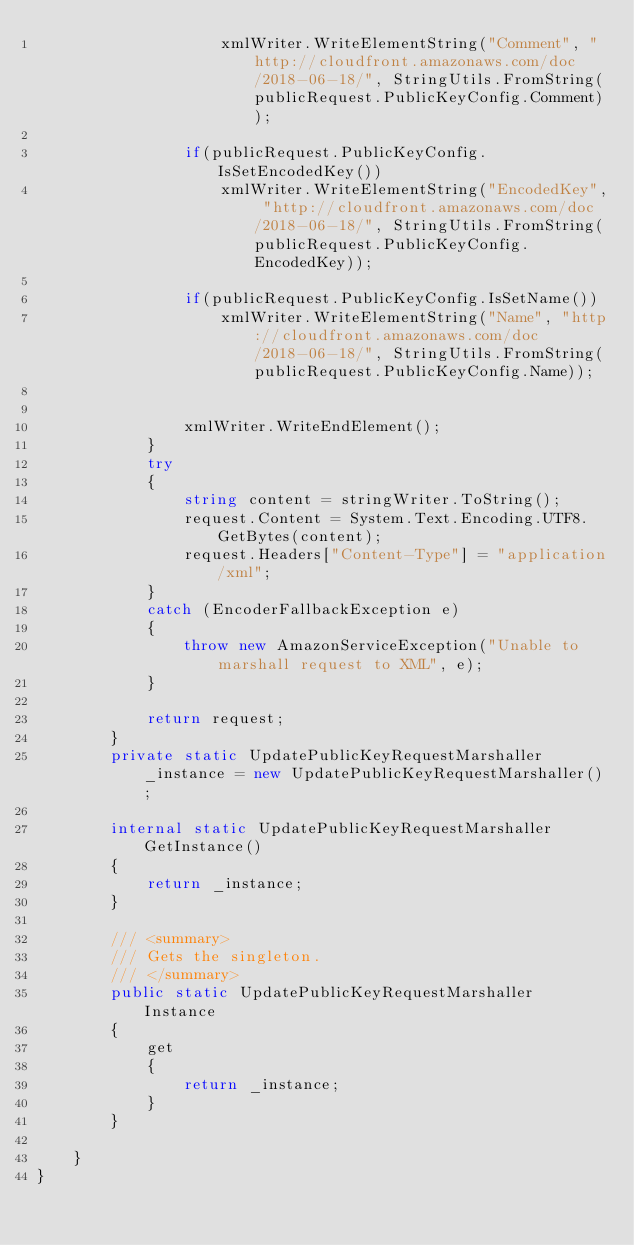Convert code to text. <code><loc_0><loc_0><loc_500><loc_500><_C#_>                    xmlWriter.WriteElementString("Comment", "http://cloudfront.amazonaws.com/doc/2018-06-18/", StringUtils.FromString(publicRequest.PublicKeyConfig.Comment));                    

                if(publicRequest.PublicKeyConfig.IsSetEncodedKey())
                    xmlWriter.WriteElementString("EncodedKey", "http://cloudfront.amazonaws.com/doc/2018-06-18/", StringUtils.FromString(publicRequest.PublicKeyConfig.EncodedKey));                    

                if(publicRequest.PublicKeyConfig.IsSetName())
                    xmlWriter.WriteElementString("Name", "http://cloudfront.amazonaws.com/doc/2018-06-18/", StringUtils.FromString(publicRequest.PublicKeyConfig.Name));                    


                xmlWriter.WriteEndElement();
            }
            try 
            {
                string content = stringWriter.ToString();
                request.Content = System.Text.Encoding.UTF8.GetBytes(content);
                request.Headers["Content-Type"] = "application/xml";
            } 
            catch (EncoderFallbackException e) 
            {
                throw new AmazonServiceException("Unable to marshall request to XML", e);
            }

            return request;
        }
        private static UpdatePublicKeyRequestMarshaller _instance = new UpdatePublicKeyRequestMarshaller();        

        internal static UpdatePublicKeyRequestMarshaller GetInstance()
        {
            return _instance;
        }

        /// <summary>
        /// Gets the singleton.
        /// </summary>  
        public static UpdatePublicKeyRequestMarshaller Instance
        {
            get
            {
                return _instance;
            }
        }

    }    
}</code> 